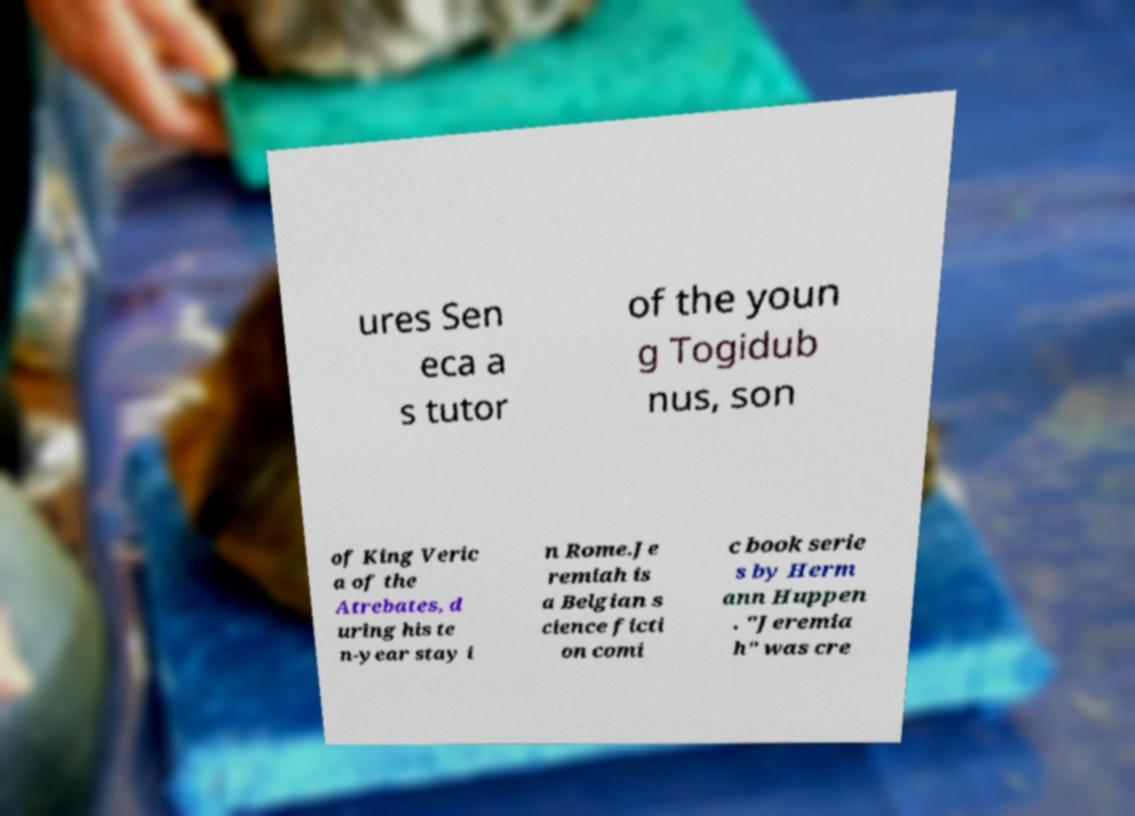There's text embedded in this image that I need extracted. Can you transcribe it verbatim? ures Sen eca a s tutor of the youn g Togidub nus, son of King Veric a of the Atrebates, d uring his te n-year stay i n Rome.Je remiah is a Belgian s cience ficti on comi c book serie s by Herm ann Huppen . "Jeremia h" was cre 